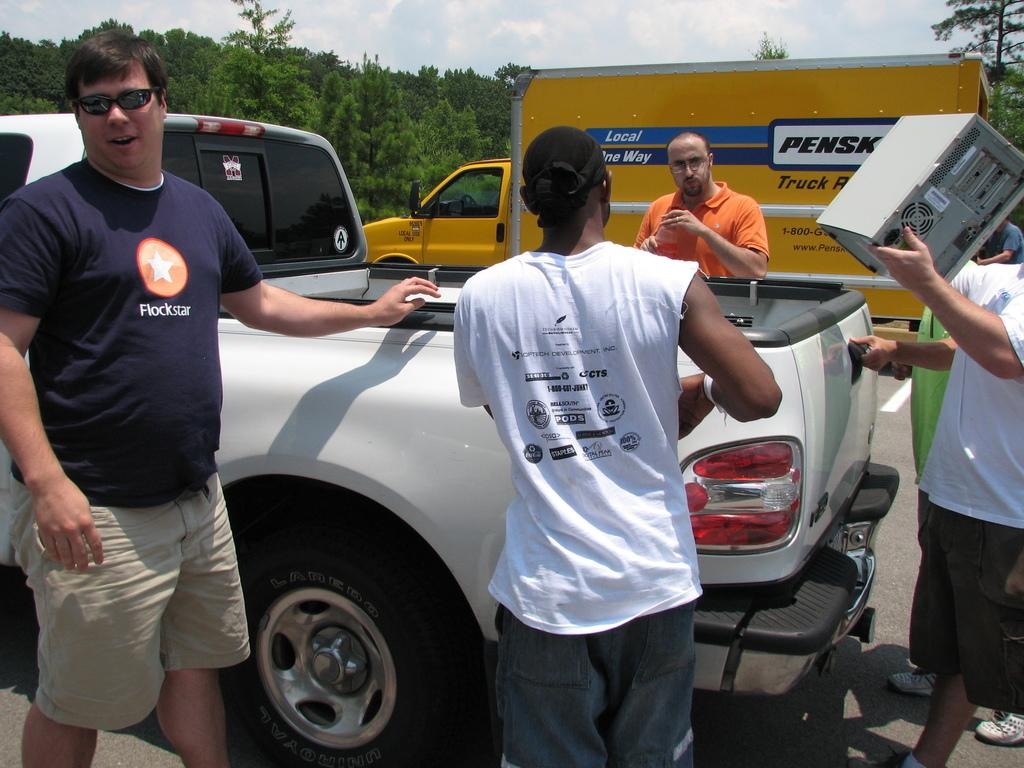How many people are in the image? There are people in the image, but the exact number is not specified. What are some people doing in the image? Some people are holding objects in the image. What types of vehicles can be seen in the image? There are vehicles in the image, but the specific types are not mentioned. What natural elements are present in the image? There are trees in the image. What is visible in the background of the image? The sky is visible in the background of the image, and clouds are present in the sky. What type of shoes is the yak wearing in the image? There is no yak present in the image, and therefore no shoes to describe. What direction is the person pointing in the image? There is no mention of a person pointing in any direction in the image. 